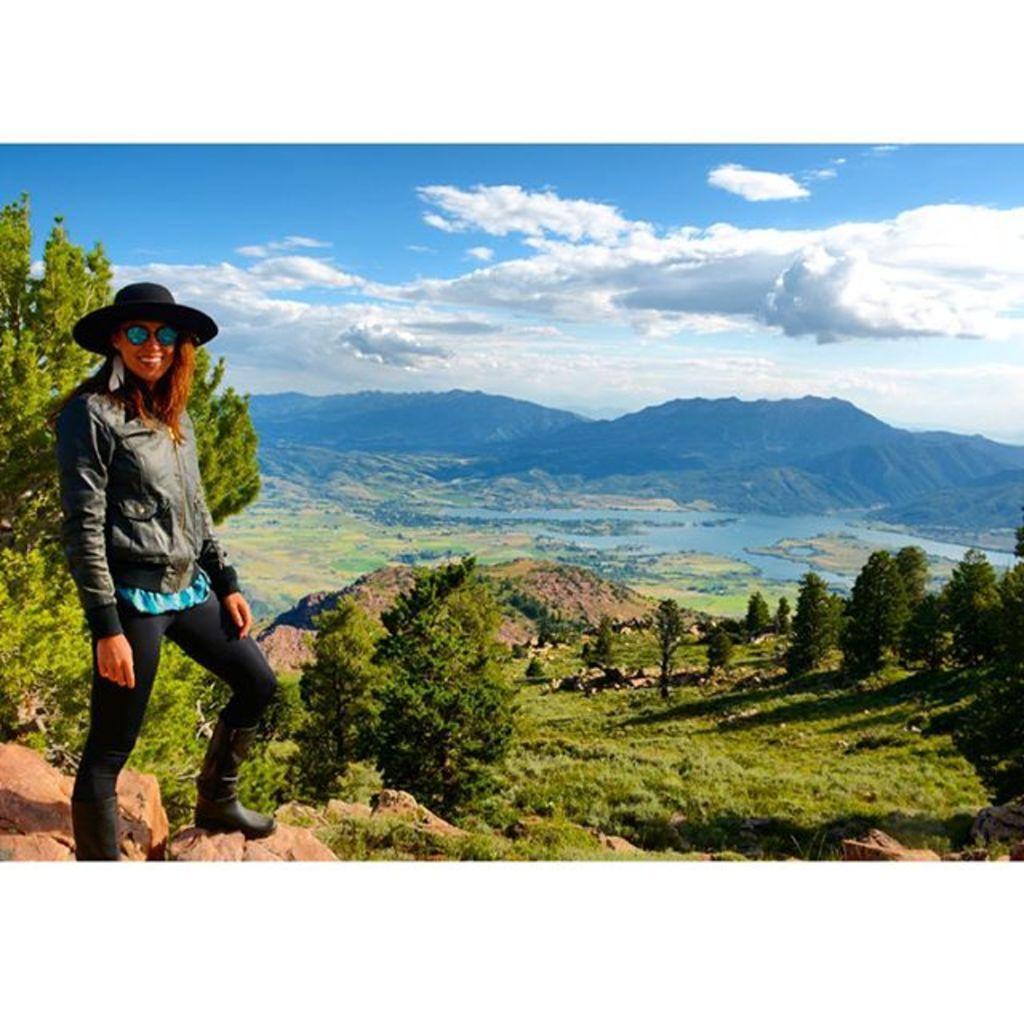Please provide a concise description of this image. In this image we can see a woman standing on the rocks. We can also see some grass, a group of trees, some plants and stones. On the backside we can see a water body, the hills and the sky which looks cloudy. 